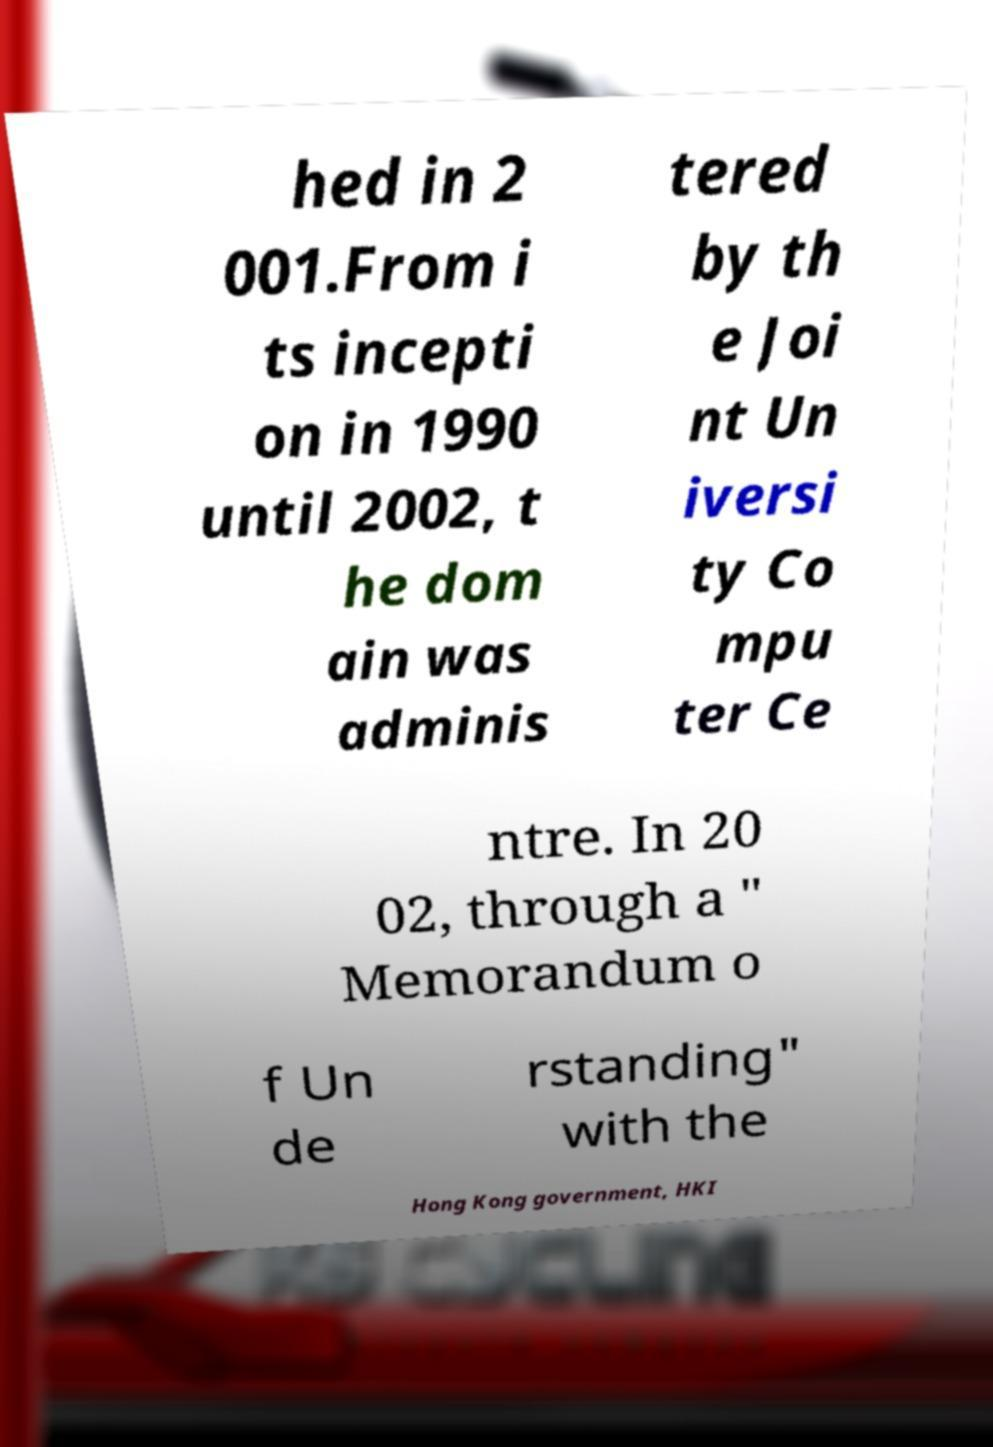For documentation purposes, I need the text within this image transcribed. Could you provide that? hed in 2 001.From i ts incepti on in 1990 until 2002, t he dom ain was adminis tered by th e Joi nt Un iversi ty Co mpu ter Ce ntre. In 20 02, through a " Memorandum o f Un de rstanding" with the Hong Kong government, HKI 